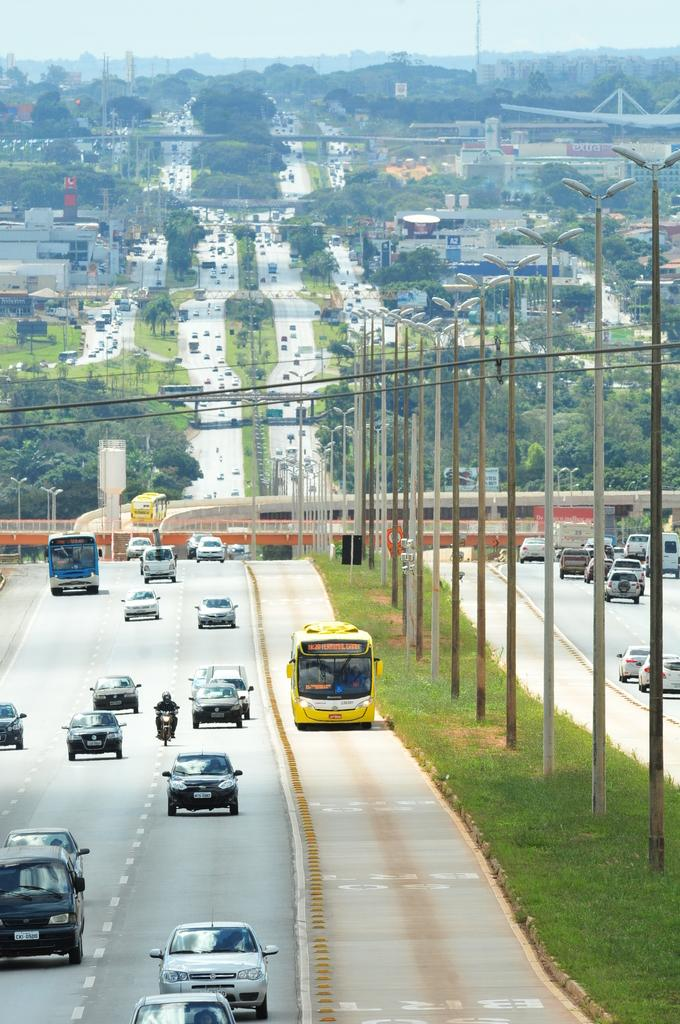What type of surface can be seen in the image? There is a road in the image. What type of vegetation is visible in the image? There is grass visible in the image. What type of structures can be seen in the image? There are poles, trees, and buildings in the image. What type of transportation is present in the image? There are vehicles in the image. What type of architectural feature can be seen in the image? There is a bridge in the image. What type of utility infrastructure is present in the image? There are wires in the image. What can be seen in the background of the image? The sky is visible in the background of the image. Can you tell me how many friends are walking on the grass in the image? There are no friends or walking individuals present in the image. What type of liquid can be seen flowing under the bridge in the image? There is no liquid visible in the image; only a road, grass, poles, trees, buildings, vehicles, wires, and the sky are present. 